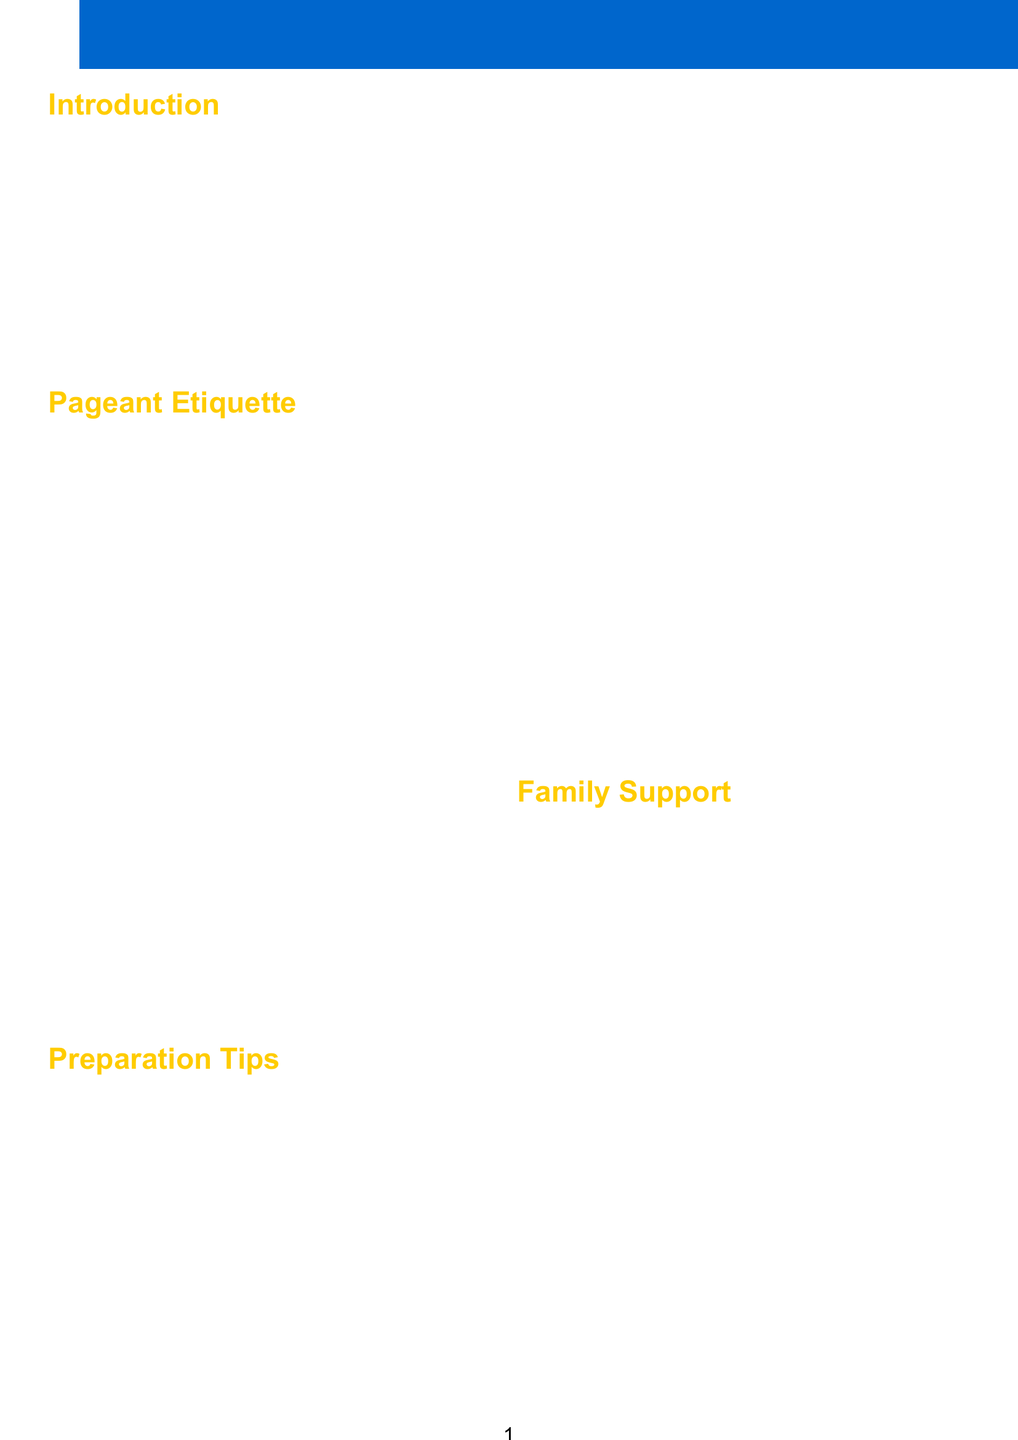what is the title of the brochure? The title of the brochure is clearly stated at the beginning of the document.
Answer: Miss Grand Nicaragua: Etiquette and Preparation Guide for Contestants and Families how many sections are in the brochure? The brochure consists of several sections, which can be counted in the document.
Answer: 5 what organization is the brochure associated with? The document specifies the name of the organization responsible for the brochure.
Answer: Miss Grand Nicaragua name one physical preparation tip mentioned. The brochure lists various tips under physical preparation, one of which can be identified.
Answer: Maintain a balanced diet rich in fruits and vegetables what should contestants incorporate in their talent portions? The document suggests incorporating a traditional element during the talent portions of the pageant.
Answer: Güegüense dance what is one way families can provide emotional support? The brochure details practical methods families can adopt to emotionally support contestants.
Answer: Provide encouragement and positive reinforcement what is the email address for contacting the organization? An email address is listed for inquiries related to the pageant in the contact information section.
Answer: info@missgrandnicaragua.org what does the brochure emphasize about the Miss Grand Nicaragua pageant? The document gives insights into the overall importance of the pageant beyond physical appearance.
Answer: Representing our country's values and culture 